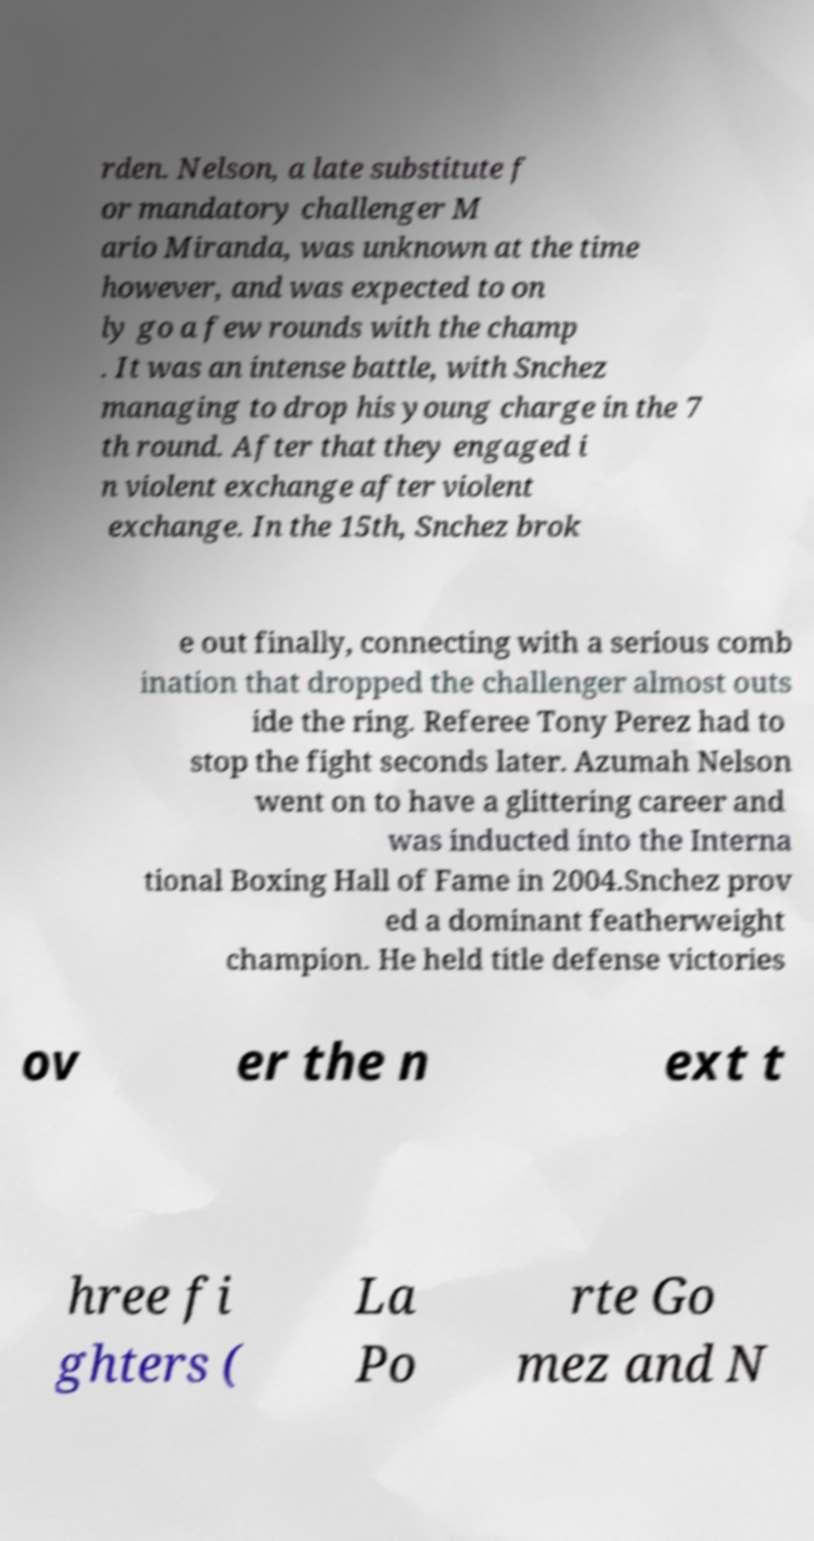Please read and relay the text visible in this image. What does it say? rden. Nelson, a late substitute f or mandatory challenger M ario Miranda, was unknown at the time however, and was expected to on ly go a few rounds with the champ . It was an intense battle, with Snchez managing to drop his young charge in the 7 th round. After that they engaged i n violent exchange after violent exchange. In the 15th, Snchez brok e out finally, connecting with a serious comb ination that dropped the challenger almost outs ide the ring. Referee Tony Perez had to stop the fight seconds later. Azumah Nelson went on to have a glittering career and was inducted into the Interna tional Boxing Hall of Fame in 2004.Snchez prov ed a dominant featherweight champion. He held title defense victories ov er the n ext t hree fi ghters ( La Po rte Go mez and N 